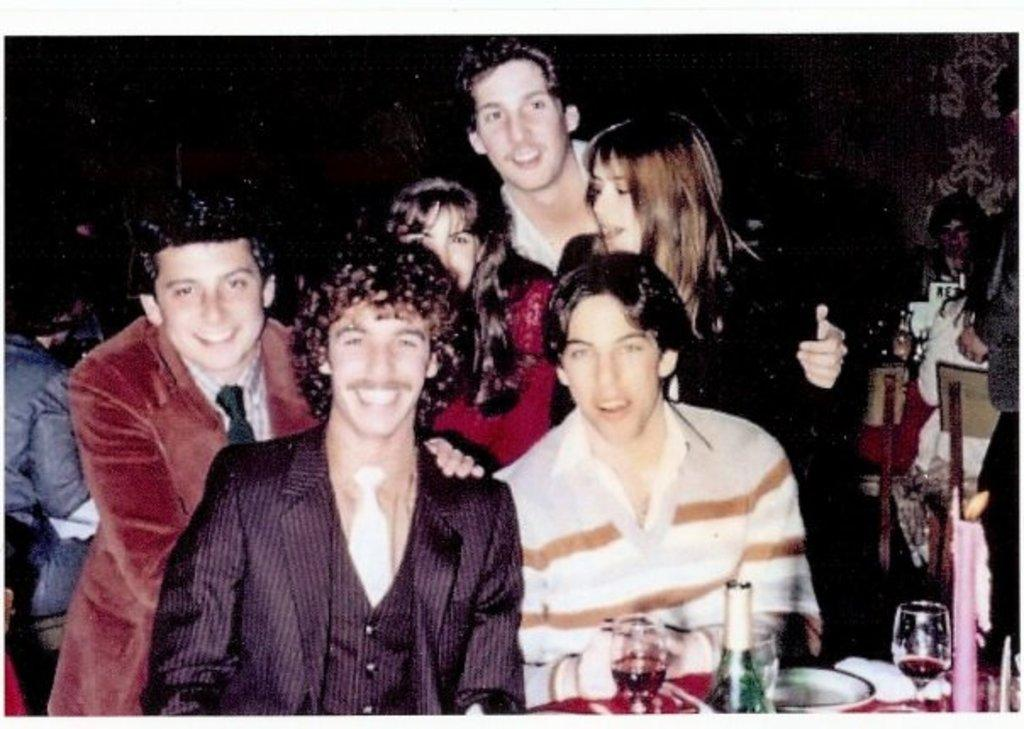How many people are in the image? There is a group of people in the image, but the exact number cannot be determined from the provided facts. What is on the table in the image? There are plates, a bottle, and glasses on the table in the image. What might be used for drinking in the image? The glasses on the table might be used for drinking. What is the lighting condition in the image? The image is slightly dark. What type of harmony is being played by the chicken in the image? There is no chicken present in the image, so it is not possible to determine if any harmony is being played. 